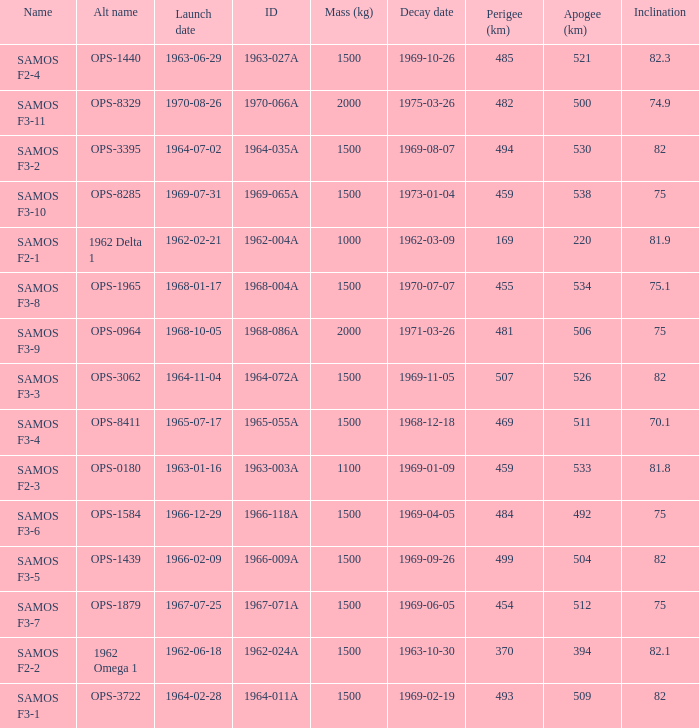What is the inclination when the alt name is OPS-1584? 75.0. 